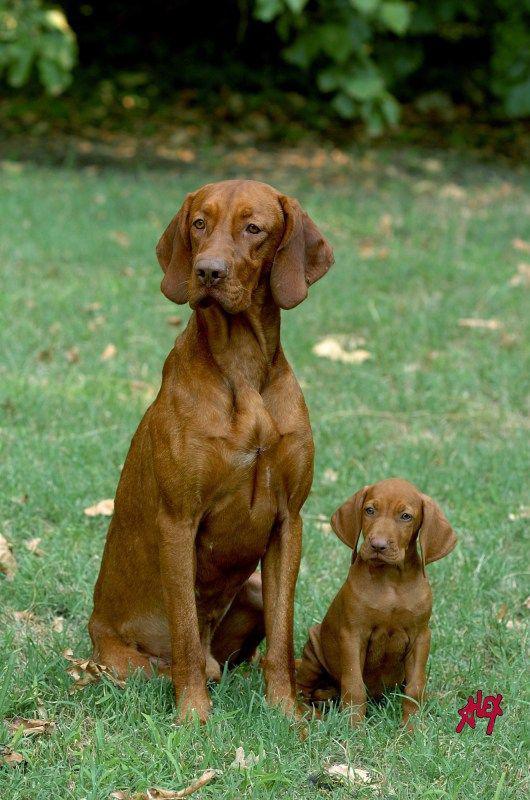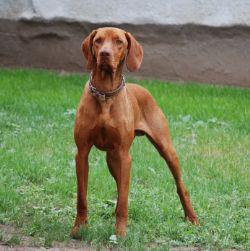The first image is the image on the left, the second image is the image on the right. For the images displayed, is the sentence "One dog is standing." factually correct? Answer yes or no. Yes. The first image is the image on the left, the second image is the image on the right. Analyze the images presented: Is the assertion "Each image contains a single dog, and the left image features a dog with its head cocked, while the right image shows a dog looking directly forward with a straight head." valid? Answer yes or no. No. 